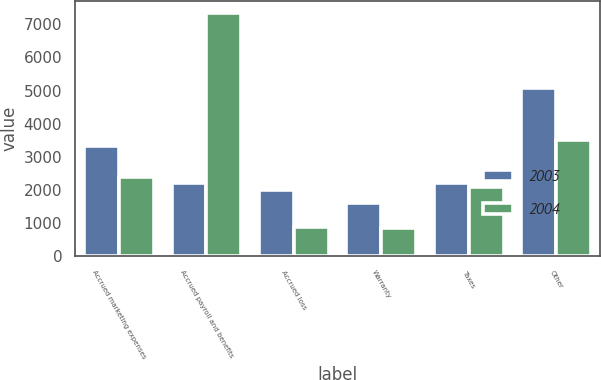<chart> <loc_0><loc_0><loc_500><loc_500><stacked_bar_chart><ecel><fcel>Accrued marketing expenses<fcel>Accrued payroll and benefits<fcel>Accrued loss<fcel>Warranty<fcel>Taxes<fcel>Other<nl><fcel>2003<fcel>3313<fcel>2201<fcel>1985<fcel>1616<fcel>2201<fcel>5090<nl><fcel>2004<fcel>2391<fcel>7348<fcel>871<fcel>862<fcel>2093<fcel>3521<nl></chart> 